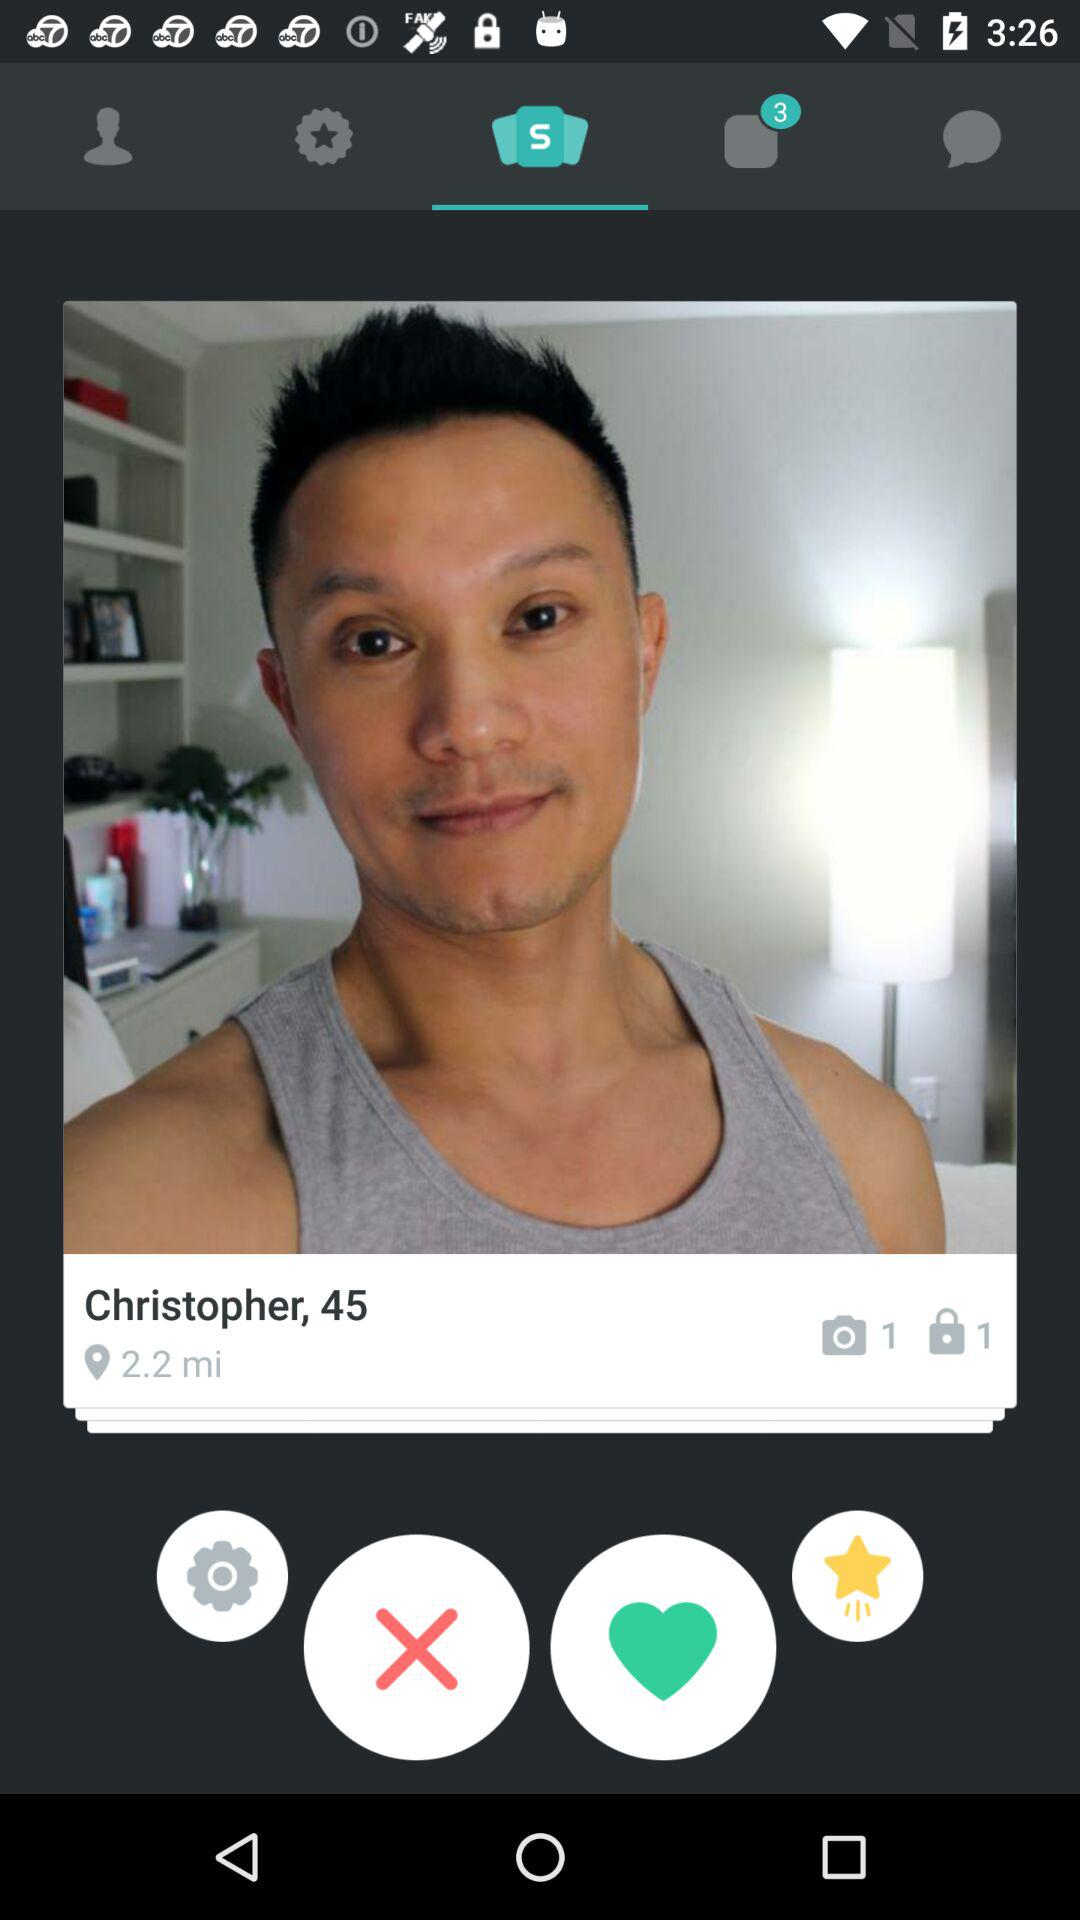What is the total number of notifications in the other tab? The total number of notifications in the other tab is 3. 